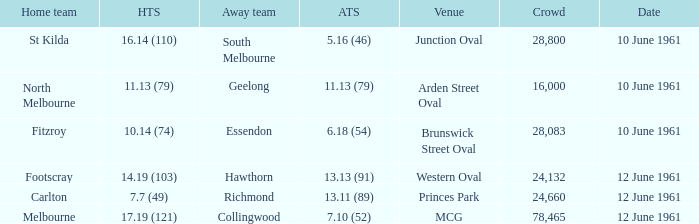What was the home team score for the Richmond away team? 7.7 (49). 